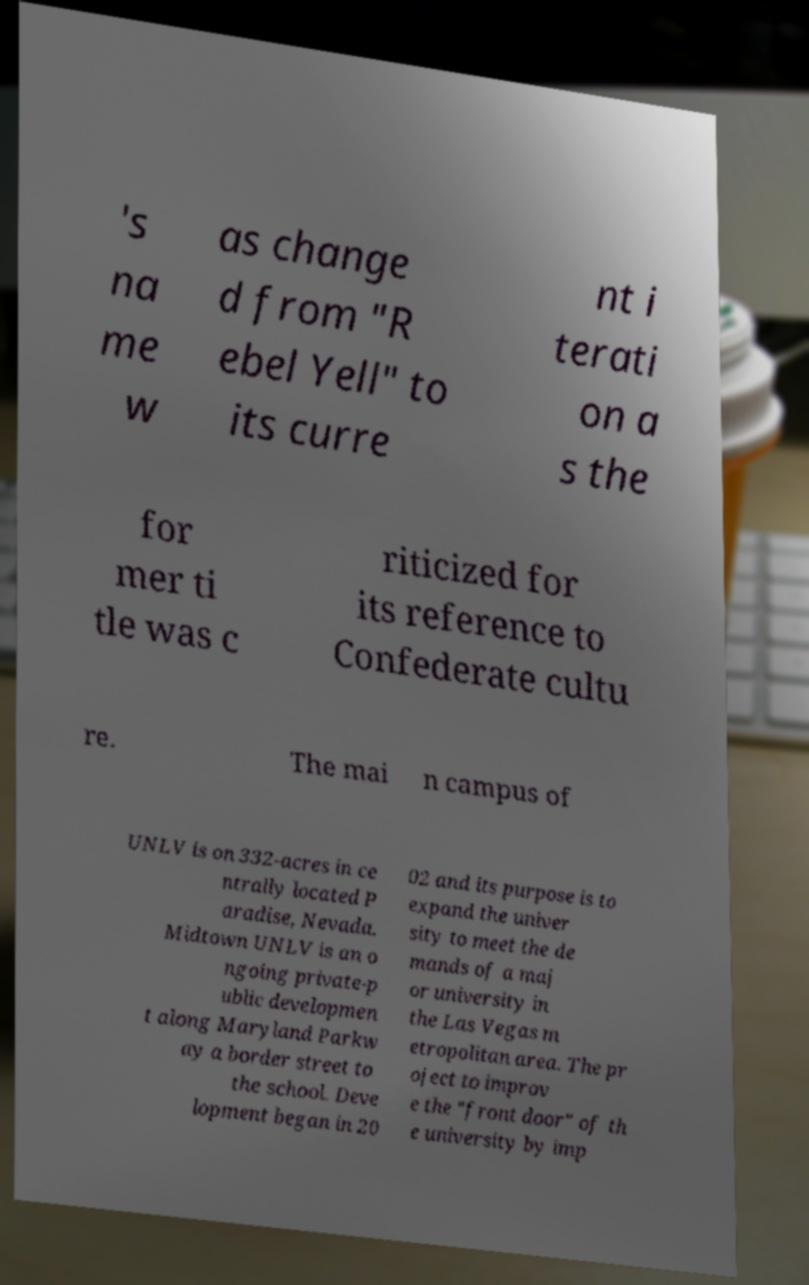Can you accurately transcribe the text from the provided image for me? 's na me w as change d from "R ebel Yell" to its curre nt i terati on a s the for mer ti tle was c riticized for its reference to Confederate cultu re. The mai n campus of UNLV is on 332-acres in ce ntrally located P aradise, Nevada. Midtown UNLV is an o ngoing private-p ublic developmen t along Maryland Parkw ay a border street to the school. Deve lopment began in 20 02 and its purpose is to expand the univer sity to meet the de mands of a maj or university in the Las Vegas m etropolitan area. The pr oject to improv e the "front door" of th e university by imp 